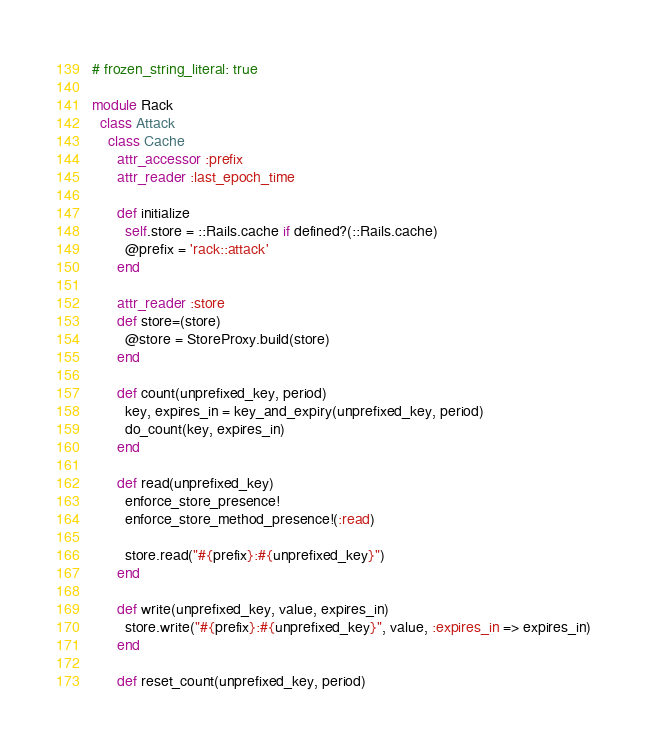Convert code to text. <code><loc_0><loc_0><loc_500><loc_500><_Ruby_># frozen_string_literal: true

module Rack
  class Attack
    class Cache
      attr_accessor :prefix
      attr_reader :last_epoch_time

      def initialize
        self.store = ::Rails.cache if defined?(::Rails.cache)
        @prefix = 'rack::attack'
      end

      attr_reader :store
      def store=(store)
        @store = StoreProxy.build(store)
      end

      def count(unprefixed_key, period)
        key, expires_in = key_and_expiry(unprefixed_key, period)
        do_count(key, expires_in)
      end

      def read(unprefixed_key)
        enforce_store_presence!
        enforce_store_method_presence!(:read)

        store.read("#{prefix}:#{unprefixed_key}")
      end

      def write(unprefixed_key, value, expires_in)
        store.write("#{prefix}:#{unprefixed_key}", value, :expires_in => expires_in)
      end

      def reset_count(unprefixed_key, period)</code> 